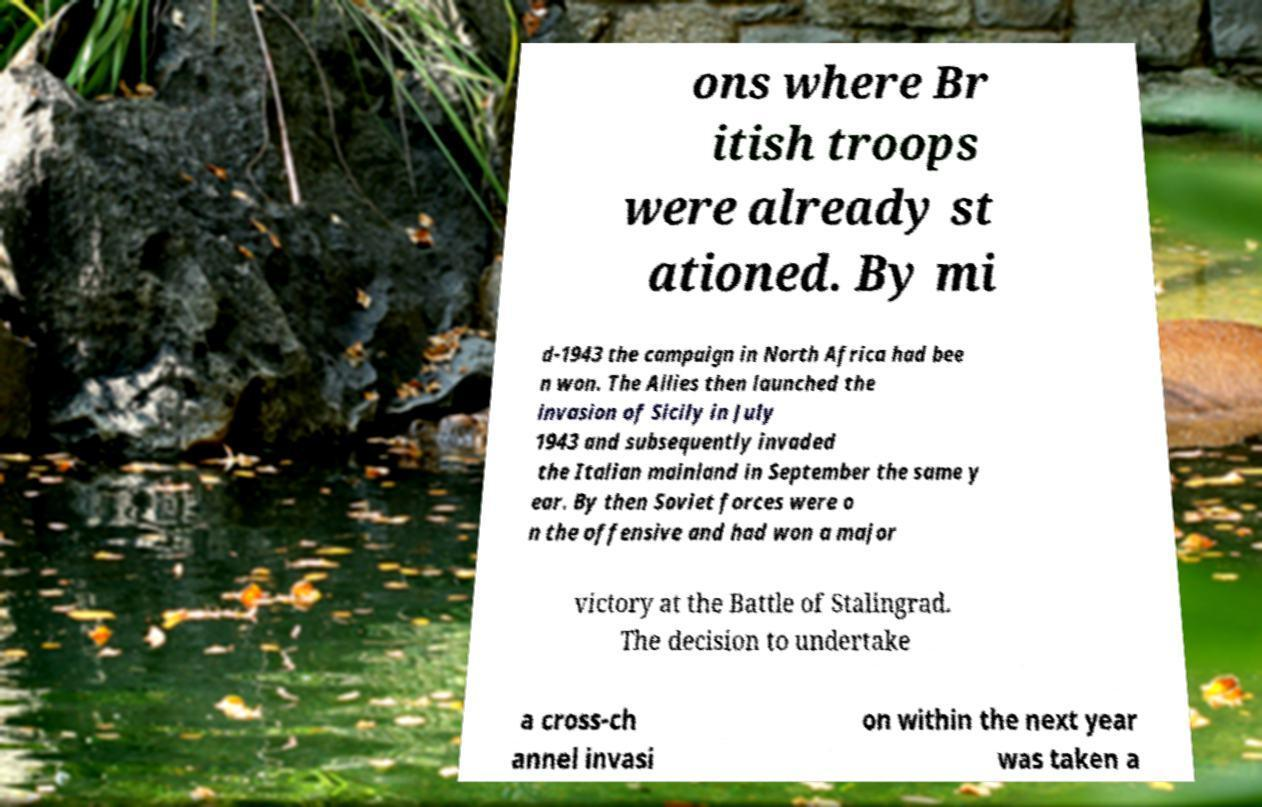Can you read and provide the text displayed in the image?This photo seems to have some interesting text. Can you extract and type it out for me? ons where Br itish troops were already st ationed. By mi d-1943 the campaign in North Africa had bee n won. The Allies then launched the invasion of Sicily in July 1943 and subsequently invaded the Italian mainland in September the same y ear. By then Soviet forces were o n the offensive and had won a major victory at the Battle of Stalingrad. The decision to undertake a cross-ch annel invasi on within the next year was taken a 